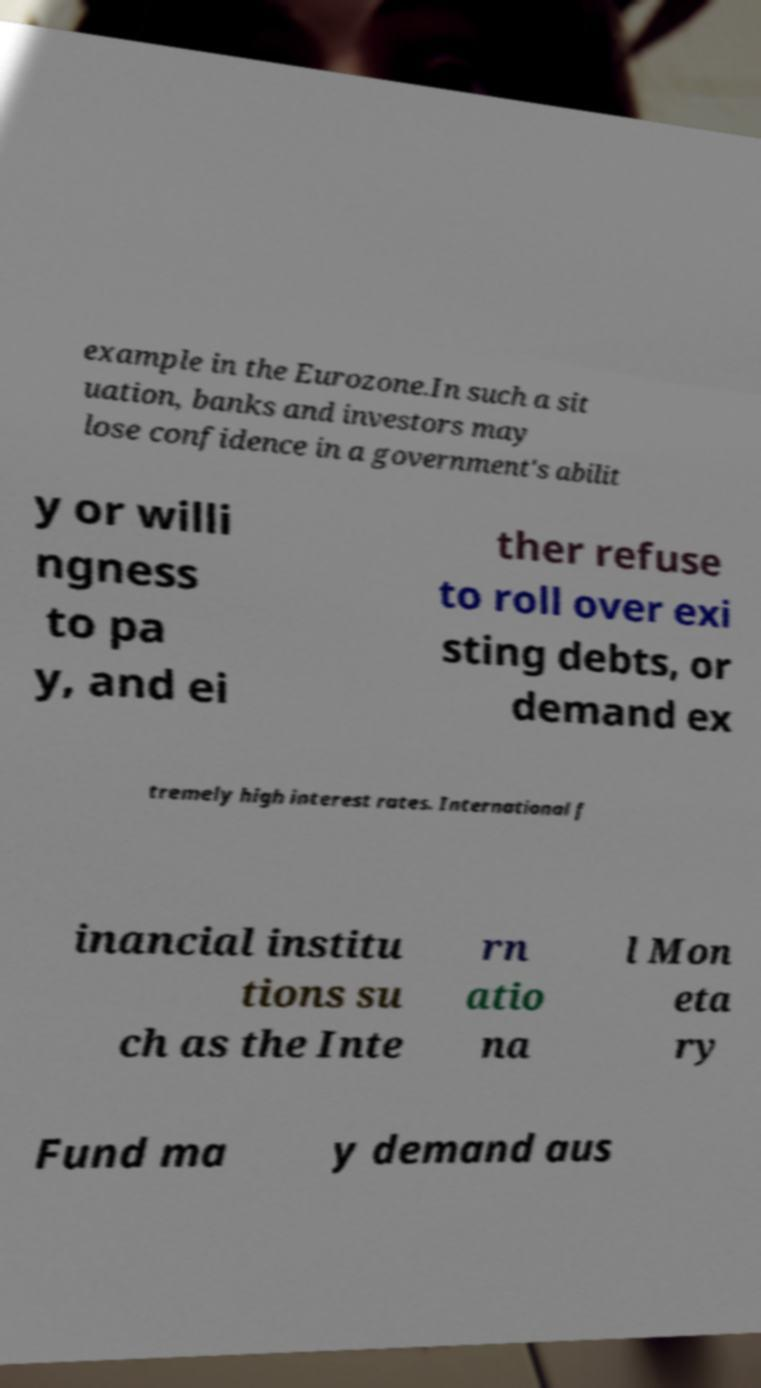There's text embedded in this image that I need extracted. Can you transcribe it verbatim? example in the Eurozone.In such a sit uation, banks and investors may lose confidence in a government's abilit y or willi ngness to pa y, and ei ther refuse to roll over exi sting debts, or demand ex tremely high interest rates. International f inancial institu tions su ch as the Inte rn atio na l Mon eta ry Fund ma y demand aus 